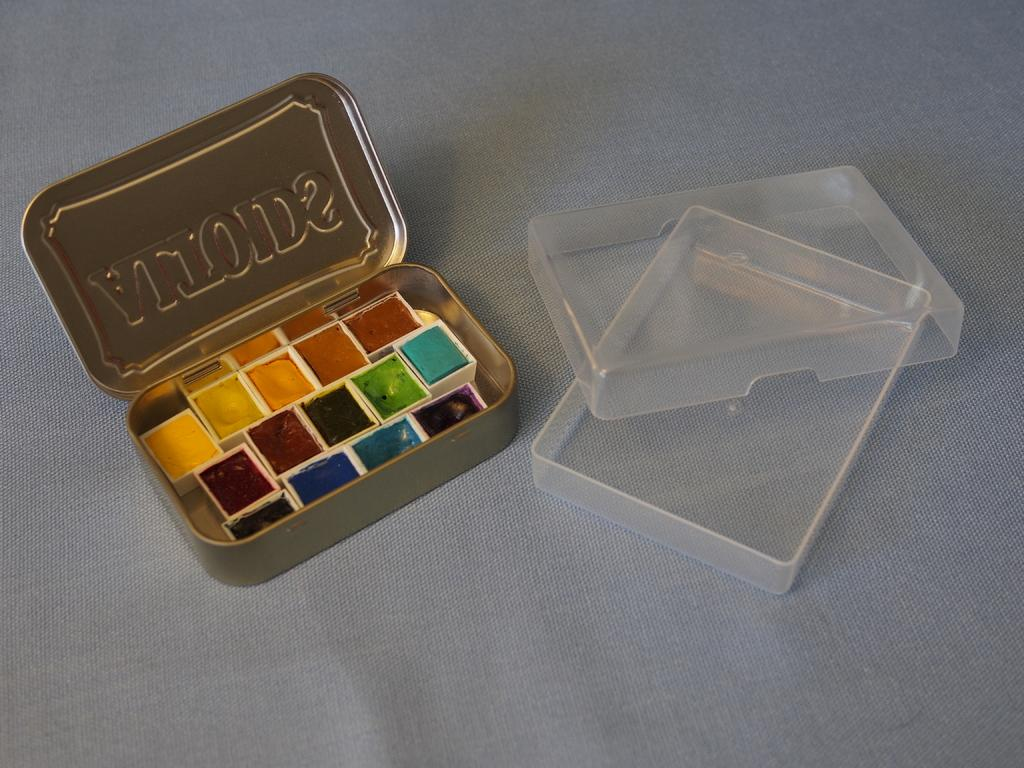<image>
Describe the image concisely. Small squares of color are placed neatly in an Altoids container 